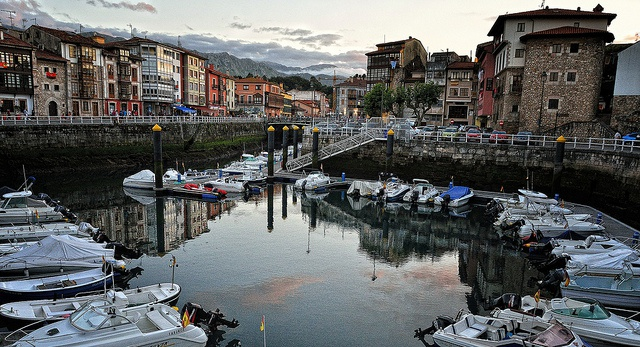Describe the objects in this image and their specific colors. I can see boat in lightblue, black, darkgray, and gray tones, boat in lightblue, darkgray, black, and gray tones, boat in lightblue, gray, darkgray, and black tones, boat in lightblue, gray, darkgray, and black tones, and boat in lightblue, darkgray, gray, and black tones in this image. 